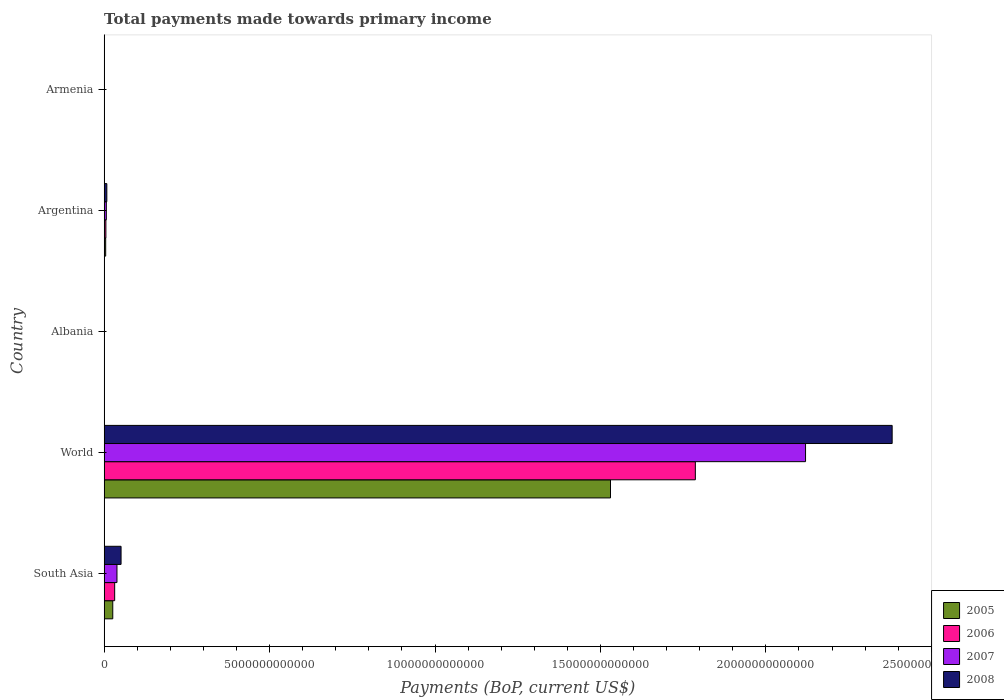How many different coloured bars are there?
Make the answer very short. 4. Are the number of bars per tick equal to the number of legend labels?
Your answer should be very brief. Yes. Are the number of bars on each tick of the Y-axis equal?
Make the answer very short. Yes. How many bars are there on the 2nd tick from the top?
Offer a terse response. 4. How many bars are there on the 3rd tick from the bottom?
Your response must be concise. 4. What is the label of the 5th group of bars from the top?
Give a very brief answer. South Asia. What is the total payments made towards primary income in 2006 in World?
Give a very brief answer. 1.79e+13. Across all countries, what is the maximum total payments made towards primary income in 2007?
Offer a terse response. 2.12e+13. Across all countries, what is the minimum total payments made towards primary income in 2008?
Give a very brief answer. 5.51e+09. In which country was the total payments made towards primary income in 2005 minimum?
Your answer should be compact. Armenia. What is the total total payments made towards primary income in 2006 in the graph?
Make the answer very short. 1.82e+13. What is the difference between the total payments made towards primary income in 2006 in Armenia and that in World?
Provide a succinct answer. -1.79e+13. What is the difference between the total payments made towards primary income in 2008 in Albania and the total payments made towards primary income in 2007 in Argentina?
Offer a very short reply. -5.86e+1. What is the average total payments made towards primary income in 2007 per country?
Your answer should be very brief. 4.33e+12. What is the difference between the total payments made towards primary income in 2006 and total payments made towards primary income in 2007 in South Asia?
Give a very brief answer. -6.95e+1. In how many countries, is the total payments made towards primary income in 2005 greater than 6000000000000 US$?
Provide a short and direct response. 1. What is the ratio of the total payments made towards primary income in 2005 in Argentina to that in World?
Make the answer very short. 0. What is the difference between the highest and the second highest total payments made towards primary income in 2008?
Offer a terse response. 2.33e+13. What is the difference between the highest and the lowest total payments made towards primary income in 2008?
Provide a short and direct response. 2.38e+13. In how many countries, is the total payments made towards primary income in 2007 greater than the average total payments made towards primary income in 2007 taken over all countries?
Your response must be concise. 1. Is the sum of the total payments made towards primary income in 2008 in Armenia and South Asia greater than the maximum total payments made towards primary income in 2005 across all countries?
Make the answer very short. No. What does the 4th bar from the top in South Asia represents?
Provide a short and direct response. 2005. What does the 2nd bar from the bottom in South Asia represents?
Offer a very short reply. 2006. How many countries are there in the graph?
Make the answer very short. 5. What is the difference between two consecutive major ticks on the X-axis?
Provide a short and direct response. 5.00e+12. Are the values on the major ticks of X-axis written in scientific E-notation?
Provide a succinct answer. No. Does the graph contain any zero values?
Give a very brief answer. No. Where does the legend appear in the graph?
Offer a very short reply. Bottom right. How are the legend labels stacked?
Your response must be concise. Vertical. What is the title of the graph?
Your answer should be compact. Total payments made towards primary income. What is the label or title of the X-axis?
Ensure brevity in your answer.  Payments (BoP, current US$). What is the label or title of the Y-axis?
Provide a succinct answer. Country. What is the Payments (BoP, current US$) in 2005 in South Asia?
Give a very brief answer. 2.61e+11. What is the Payments (BoP, current US$) in 2006 in South Asia?
Your response must be concise. 3.18e+11. What is the Payments (BoP, current US$) in 2007 in South Asia?
Your answer should be very brief. 3.88e+11. What is the Payments (BoP, current US$) in 2008 in South Asia?
Your answer should be very brief. 5.11e+11. What is the Payments (BoP, current US$) in 2005 in World?
Your answer should be very brief. 1.53e+13. What is the Payments (BoP, current US$) in 2006 in World?
Give a very brief answer. 1.79e+13. What is the Payments (BoP, current US$) of 2007 in World?
Make the answer very short. 2.12e+13. What is the Payments (BoP, current US$) in 2008 in World?
Your response must be concise. 2.38e+13. What is the Payments (BoP, current US$) of 2005 in Albania?
Offer a very short reply. 3.55e+09. What is the Payments (BoP, current US$) in 2006 in Albania?
Your answer should be very brief. 4.14e+09. What is the Payments (BoP, current US$) in 2007 in Albania?
Offer a terse response. 5.43e+09. What is the Payments (BoP, current US$) in 2008 in Albania?
Give a very brief answer. 7.15e+09. What is the Payments (BoP, current US$) in 2005 in Argentina?
Ensure brevity in your answer.  4.64e+1. What is the Payments (BoP, current US$) in 2006 in Argentina?
Offer a terse response. 5.28e+1. What is the Payments (BoP, current US$) in 2007 in Argentina?
Offer a very short reply. 6.58e+1. What is the Payments (BoP, current US$) of 2008 in Argentina?
Make the answer very short. 8.10e+1. What is the Payments (BoP, current US$) of 2005 in Armenia?
Make the answer very short. 2.52e+09. What is the Payments (BoP, current US$) in 2006 in Armenia?
Offer a terse response. 3.04e+09. What is the Payments (BoP, current US$) of 2007 in Armenia?
Provide a succinct answer. 4.33e+09. What is the Payments (BoP, current US$) in 2008 in Armenia?
Ensure brevity in your answer.  5.51e+09. Across all countries, what is the maximum Payments (BoP, current US$) in 2005?
Ensure brevity in your answer.  1.53e+13. Across all countries, what is the maximum Payments (BoP, current US$) of 2006?
Your answer should be very brief. 1.79e+13. Across all countries, what is the maximum Payments (BoP, current US$) in 2007?
Keep it short and to the point. 2.12e+13. Across all countries, what is the maximum Payments (BoP, current US$) of 2008?
Offer a very short reply. 2.38e+13. Across all countries, what is the minimum Payments (BoP, current US$) of 2005?
Make the answer very short. 2.52e+09. Across all countries, what is the minimum Payments (BoP, current US$) of 2006?
Keep it short and to the point. 3.04e+09. Across all countries, what is the minimum Payments (BoP, current US$) of 2007?
Your answer should be very brief. 4.33e+09. Across all countries, what is the minimum Payments (BoP, current US$) in 2008?
Offer a very short reply. 5.51e+09. What is the total Payments (BoP, current US$) of 2005 in the graph?
Offer a very short reply. 1.56e+13. What is the total Payments (BoP, current US$) in 2006 in the graph?
Your response must be concise. 1.82e+13. What is the total Payments (BoP, current US$) of 2007 in the graph?
Provide a succinct answer. 2.17e+13. What is the total Payments (BoP, current US$) in 2008 in the graph?
Ensure brevity in your answer.  2.44e+13. What is the difference between the Payments (BoP, current US$) in 2005 in South Asia and that in World?
Provide a succinct answer. -1.50e+13. What is the difference between the Payments (BoP, current US$) of 2006 in South Asia and that in World?
Give a very brief answer. -1.75e+13. What is the difference between the Payments (BoP, current US$) in 2007 in South Asia and that in World?
Provide a succinct answer. -2.08e+13. What is the difference between the Payments (BoP, current US$) in 2008 in South Asia and that in World?
Keep it short and to the point. -2.33e+13. What is the difference between the Payments (BoP, current US$) in 2005 in South Asia and that in Albania?
Keep it short and to the point. 2.57e+11. What is the difference between the Payments (BoP, current US$) in 2006 in South Asia and that in Albania?
Ensure brevity in your answer.  3.14e+11. What is the difference between the Payments (BoP, current US$) in 2007 in South Asia and that in Albania?
Offer a very short reply. 3.82e+11. What is the difference between the Payments (BoP, current US$) in 2008 in South Asia and that in Albania?
Provide a succinct answer. 5.04e+11. What is the difference between the Payments (BoP, current US$) in 2005 in South Asia and that in Argentina?
Ensure brevity in your answer.  2.14e+11. What is the difference between the Payments (BoP, current US$) of 2006 in South Asia and that in Argentina?
Your answer should be very brief. 2.65e+11. What is the difference between the Payments (BoP, current US$) of 2007 in South Asia and that in Argentina?
Your answer should be very brief. 3.22e+11. What is the difference between the Payments (BoP, current US$) in 2008 in South Asia and that in Argentina?
Provide a short and direct response. 4.30e+11. What is the difference between the Payments (BoP, current US$) in 2005 in South Asia and that in Armenia?
Give a very brief answer. 2.58e+11. What is the difference between the Payments (BoP, current US$) of 2006 in South Asia and that in Armenia?
Make the answer very short. 3.15e+11. What is the difference between the Payments (BoP, current US$) in 2007 in South Asia and that in Armenia?
Your answer should be compact. 3.83e+11. What is the difference between the Payments (BoP, current US$) in 2008 in South Asia and that in Armenia?
Offer a terse response. 5.06e+11. What is the difference between the Payments (BoP, current US$) of 2005 in World and that in Albania?
Offer a terse response. 1.53e+13. What is the difference between the Payments (BoP, current US$) of 2006 in World and that in Albania?
Your answer should be very brief. 1.79e+13. What is the difference between the Payments (BoP, current US$) in 2007 in World and that in Albania?
Ensure brevity in your answer.  2.12e+13. What is the difference between the Payments (BoP, current US$) of 2008 in World and that in Albania?
Make the answer very short. 2.38e+13. What is the difference between the Payments (BoP, current US$) of 2005 in World and that in Argentina?
Your answer should be very brief. 1.53e+13. What is the difference between the Payments (BoP, current US$) of 2006 in World and that in Argentina?
Offer a terse response. 1.78e+13. What is the difference between the Payments (BoP, current US$) of 2007 in World and that in Argentina?
Your response must be concise. 2.11e+13. What is the difference between the Payments (BoP, current US$) of 2008 in World and that in Argentina?
Provide a succinct answer. 2.37e+13. What is the difference between the Payments (BoP, current US$) in 2005 in World and that in Armenia?
Your response must be concise. 1.53e+13. What is the difference between the Payments (BoP, current US$) of 2006 in World and that in Armenia?
Provide a succinct answer. 1.79e+13. What is the difference between the Payments (BoP, current US$) of 2007 in World and that in Armenia?
Keep it short and to the point. 2.12e+13. What is the difference between the Payments (BoP, current US$) in 2008 in World and that in Armenia?
Ensure brevity in your answer.  2.38e+13. What is the difference between the Payments (BoP, current US$) of 2005 in Albania and that in Argentina?
Offer a terse response. -4.29e+1. What is the difference between the Payments (BoP, current US$) in 2006 in Albania and that in Argentina?
Your answer should be very brief. -4.87e+1. What is the difference between the Payments (BoP, current US$) of 2007 in Albania and that in Argentina?
Ensure brevity in your answer.  -6.04e+1. What is the difference between the Payments (BoP, current US$) in 2008 in Albania and that in Argentina?
Give a very brief answer. -7.39e+1. What is the difference between the Payments (BoP, current US$) of 2005 in Albania and that in Armenia?
Keep it short and to the point. 1.03e+09. What is the difference between the Payments (BoP, current US$) of 2006 in Albania and that in Armenia?
Your answer should be compact. 1.11e+09. What is the difference between the Payments (BoP, current US$) in 2007 in Albania and that in Armenia?
Offer a very short reply. 1.09e+09. What is the difference between the Payments (BoP, current US$) of 2008 in Albania and that in Armenia?
Provide a succinct answer. 1.64e+09. What is the difference between the Payments (BoP, current US$) in 2005 in Argentina and that in Armenia?
Your answer should be compact. 4.39e+1. What is the difference between the Payments (BoP, current US$) in 2006 in Argentina and that in Armenia?
Offer a very short reply. 4.98e+1. What is the difference between the Payments (BoP, current US$) in 2007 in Argentina and that in Armenia?
Your answer should be very brief. 6.15e+1. What is the difference between the Payments (BoP, current US$) of 2008 in Argentina and that in Armenia?
Provide a succinct answer. 7.55e+1. What is the difference between the Payments (BoP, current US$) in 2005 in South Asia and the Payments (BoP, current US$) in 2006 in World?
Keep it short and to the point. -1.76e+13. What is the difference between the Payments (BoP, current US$) of 2005 in South Asia and the Payments (BoP, current US$) of 2007 in World?
Keep it short and to the point. -2.09e+13. What is the difference between the Payments (BoP, current US$) in 2005 in South Asia and the Payments (BoP, current US$) in 2008 in World?
Keep it short and to the point. -2.36e+13. What is the difference between the Payments (BoP, current US$) in 2006 in South Asia and the Payments (BoP, current US$) in 2007 in World?
Provide a short and direct response. -2.09e+13. What is the difference between the Payments (BoP, current US$) of 2006 in South Asia and the Payments (BoP, current US$) of 2008 in World?
Ensure brevity in your answer.  -2.35e+13. What is the difference between the Payments (BoP, current US$) in 2007 in South Asia and the Payments (BoP, current US$) in 2008 in World?
Keep it short and to the point. -2.34e+13. What is the difference between the Payments (BoP, current US$) of 2005 in South Asia and the Payments (BoP, current US$) of 2006 in Albania?
Your response must be concise. 2.56e+11. What is the difference between the Payments (BoP, current US$) in 2005 in South Asia and the Payments (BoP, current US$) in 2007 in Albania?
Your answer should be very brief. 2.55e+11. What is the difference between the Payments (BoP, current US$) of 2005 in South Asia and the Payments (BoP, current US$) of 2008 in Albania?
Give a very brief answer. 2.53e+11. What is the difference between the Payments (BoP, current US$) in 2006 in South Asia and the Payments (BoP, current US$) in 2007 in Albania?
Make the answer very short. 3.13e+11. What is the difference between the Payments (BoP, current US$) in 2006 in South Asia and the Payments (BoP, current US$) in 2008 in Albania?
Make the answer very short. 3.11e+11. What is the difference between the Payments (BoP, current US$) of 2007 in South Asia and the Payments (BoP, current US$) of 2008 in Albania?
Your answer should be compact. 3.80e+11. What is the difference between the Payments (BoP, current US$) in 2005 in South Asia and the Payments (BoP, current US$) in 2006 in Argentina?
Offer a terse response. 2.08e+11. What is the difference between the Payments (BoP, current US$) in 2005 in South Asia and the Payments (BoP, current US$) in 2007 in Argentina?
Offer a very short reply. 1.95e+11. What is the difference between the Payments (BoP, current US$) of 2005 in South Asia and the Payments (BoP, current US$) of 2008 in Argentina?
Your answer should be compact. 1.79e+11. What is the difference between the Payments (BoP, current US$) in 2006 in South Asia and the Payments (BoP, current US$) in 2007 in Argentina?
Make the answer very short. 2.52e+11. What is the difference between the Payments (BoP, current US$) of 2006 in South Asia and the Payments (BoP, current US$) of 2008 in Argentina?
Your answer should be compact. 2.37e+11. What is the difference between the Payments (BoP, current US$) in 2007 in South Asia and the Payments (BoP, current US$) in 2008 in Argentina?
Provide a succinct answer. 3.07e+11. What is the difference between the Payments (BoP, current US$) of 2005 in South Asia and the Payments (BoP, current US$) of 2006 in Armenia?
Keep it short and to the point. 2.57e+11. What is the difference between the Payments (BoP, current US$) in 2005 in South Asia and the Payments (BoP, current US$) in 2007 in Armenia?
Your response must be concise. 2.56e+11. What is the difference between the Payments (BoP, current US$) in 2005 in South Asia and the Payments (BoP, current US$) in 2008 in Armenia?
Provide a succinct answer. 2.55e+11. What is the difference between the Payments (BoP, current US$) of 2006 in South Asia and the Payments (BoP, current US$) of 2007 in Armenia?
Your response must be concise. 3.14e+11. What is the difference between the Payments (BoP, current US$) in 2006 in South Asia and the Payments (BoP, current US$) in 2008 in Armenia?
Your answer should be very brief. 3.12e+11. What is the difference between the Payments (BoP, current US$) in 2007 in South Asia and the Payments (BoP, current US$) in 2008 in Armenia?
Make the answer very short. 3.82e+11. What is the difference between the Payments (BoP, current US$) in 2005 in World and the Payments (BoP, current US$) in 2006 in Albania?
Your response must be concise. 1.53e+13. What is the difference between the Payments (BoP, current US$) of 2005 in World and the Payments (BoP, current US$) of 2007 in Albania?
Offer a very short reply. 1.53e+13. What is the difference between the Payments (BoP, current US$) in 2005 in World and the Payments (BoP, current US$) in 2008 in Albania?
Ensure brevity in your answer.  1.53e+13. What is the difference between the Payments (BoP, current US$) in 2006 in World and the Payments (BoP, current US$) in 2007 in Albania?
Ensure brevity in your answer.  1.79e+13. What is the difference between the Payments (BoP, current US$) of 2006 in World and the Payments (BoP, current US$) of 2008 in Albania?
Keep it short and to the point. 1.79e+13. What is the difference between the Payments (BoP, current US$) of 2007 in World and the Payments (BoP, current US$) of 2008 in Albania?
Provide a short and direct response. 2.12e+13. What is the difference between the Payments (BoP, current US$) in 2005 in World and the Payments (BoP, current US$) in 2006 in Argentina?
Give a very brief answer. 1.53e+13. What is the difference between the Payments (BoP, current US$) in 2005 in World and the Payments (BoP, current US$) in 2007 in Argentina?
Provide a short and direct response. 1.52e+13. What is the difference between the Payments (BoP, current US$) in 2005 in World and the Payments (BoP, current US$) in 2008 in Argentina?
Your response must be concise. 1.52e+13. What is the difference between the Payments (BoP, current US$) of 2006 in World and the Payments (BoP, current US$) of 2007 in Argentina?
Offer a terse response. 1.78e+13. What is the difference between the Payments (BoP, current US$) of 2006 in World and the Payments (BoP, current US$) of 2008 in Argentina?
Keep it short and to the point. 1.78e+13. What is the difference between the Payments (BoP, current US$) of 2007 in World and the Payments (BoP, current US$) of 2008 in Argentina?
Provide a succinct answer. 2.11e+13. What is the difference between the Payments (BoP, current US$) in 2005 in World and the Payments (BoP, current US$) in 2006 in Armenia?
Provide a succinct answer. 1.53e+13. What is the difference between the Payments (BoP, current US$) in 2005 in World and the Payments (BoP, current US$) in 2007 in Armenia?
Provide a short and direct response. 1.53e+13. What is the difference between the Payments (BoP, current US$) in 2005 in World and the Payments (BoP, current US$) in 2008 in Armenia?
Your response must be concise. 1.53e+13. What is the difference between the Payments (BoP, current US$) of 2006 in World and the Payments (BoP, current US$) of 2007 in Armenia?
Your answer should be compact. 1.79e+13. What is the difference between the Payments (BoP, current US$) in 2006 in World and the Payments (BoP, current US$) in 2008 in Armenia?
Ensure brevity in your answer.  1.79e+13. What is the difference between the Payments (BoP, current US$) of 2007 in World and the Payments (BoP, current US$) of 2008 in Armenia?
Give a very brief answer. 2.12e+13. What is the difference between the Payments (BoP, current US$) in 2005 in Albania and the Payments (BoP, current US$) in 2006 in Argentina?
Provide a short and direct response. -4.93e+1. What is the difference between the Payments (BoP, current US$) of 2005 in Albania and the Payments (BoP, current US$) of 2007 in Argentina?
Provide a short and direct response. -6.22e+1. What is the difference between the Payments (BoP, current US$) in 2005 in Albania and the Payments (BoP, current US$) in 2008 in Argentina?
Ensure brevity in your answer.  -7.75e+1. What is the difference between the Payments (BoP, current US$) of 2006 in Albania and the Payments (BoP, current US$) of 2007 in Argentina?
Make the answer very short. -6.17e+1. What is the difference between the Payments (BoP, current US$) of 2006 in Albania and the Payments (BoP, current US$) of 2008 in Argentina?
Your answer should be compact. -7.69e+1. What is the difference between the Payments (BoP, current US$) of 2007 in Albania and the Payments (BoP, current US$) of 2008 in Argentina?
Provide a short and direct response. -7.56e+1. What is the difference between the Payments (BoP, current US$) of 2005 in Albania and the Payments (BoP, current US$) of 2006 in Armenia?
Provide a short and direct response. 5.17e+08. What is the difference between the Payments (BoP, current US$) of 2005 in Albania and the Payments (BoP, current US$) of 2007 in Armenia?
Make the answer very short. -7.81e+08. What is the difference between the Payments (BoP, current US$) in 2005 in Albania and the Payments (BoP, current US$) in 2008 in Armenia?
Offer a terse response. -1.96e+09. What is the difference between the Payments (BoP, current US$) of 2006 in Albania and the Payments (BoP, current US$) of 2007 in Armenia?
Ensure brevity in your answer.  -1.92e+08. What is the difference between the Payments (BoP, current US$) in 2006 in Albania and the Payments (BoP, current US$) in 2008 in Armenia?
Provide a succinct answer. -1.37e+09. What is the difference between the Payments (BoP, current US$) of 2007 in Albania and the Payments (BoP, current US$) of 2008 in Armenia?
Offer a very short reply. -8.38e+07. What is the difference between the Payments (BoP, current US$) in 2005 in Argentina and the Payments (BoP, current US$) in 2006 in Armenia?
Provide a short and direct response. 4.34e+1. What is the difference between the Payments (BoP, current US$) of 2005 in Argentina and the Payments (BoP, current US$) of 2007 in Armenia?
Offer a terse response. 4.21e+1. What is the difference between the Payments (BoP, current US$) in 2005 in Argentina and the Payments (BoP, current US$) in 2008 in Armenia?
Ensure brevity in your answer.  4.09e+1. What is the difference between the Payments (BoP, current US$) in 2006 in Argentina and the Payments (BoP, current US$) in 2007 in Armenia?
Your answer should be compact. 4.85e+1. What is the difference between the Payments (BoP, current US$) of 2006 in Argentina and the Payments (BoP, current US$) of 2008 in Armenia?
Offer a terse response. 4.73e+1. What is the difference between the Payments (BoP, current US$) of 2007 in Argentina and the Payments (BoP, current US$) of 2008 in Armenia?
Give a very brief answer. 6.03e+1. What is the average Payments (BoP, current US$) in 2005 per country?
Offer a terse response. 3.12e+12. What is the average Payments (BoP, current US$) of 2006 per country?
Your answer should be very brief. 3.65e+12. What is the average Payments (BoP, current US$) in 2007 per country?
Ensure brevity in your answer.  4.33e+12. What is the average Payments (BoP, current US$) of 2008 per country?
Keep it short and to the point. 4.88e+12. What is the difference between the Payments (BoP, current US$) of 2005 and Payments (BoP, current US$) of 2006 in South Asia?
Offer a very short reply. -5.75e+1. What is the difference between the Payments (BoP, current US$) in 2005 and Payments (BoP, current US$) in 2007 in South Asia?
Your answer should be compact. -1.27e+11. What is the difference between the Payments (BoP, current US$) in 2005 and Payments (BoP, current US$) in 2008 in South Asia?
Provide a succinct answer. -2.51e+11. What is the difference between the Payments (BoP, current US$) in 2006 and Payments (BoP, current US$) in 2007 in South Asia?
Provide a short and direct response. -6.95e+1. What is the difference between the Payments (BoP, current US$) of 2006 and Payments (BoP, current US$) of 2008 in South Asia?
Your answer should be compact. -1.93e+11. What is the difference between the Payments (BoP, current US$) in 2007 and Payments (BoP, current US$) in 2008 in South Asia?
Offer a terse response. -1.24e+11. What is the difference between the Payments (BoP, current US$) of 2005 and Payments (BoP, current US$) of 2006 in World?
Provide a short and direct response. -2.56e+12. What is the difference between the Payments (BoP, current US$) of 2005 and Payments (BoP, current US$) of 2007 in World?
Provide a short and direct response. -5.89e+12. What is the difference between the Payments (BoP, current US$) in 2005 and Payments (BoP, current US$) in 2008 in World?
Offer a very short reply. -8.51e+12. What is the difference between the Payments (BoP, current US$) of 2006 and Payments (BoP, current US$) of 2007 in World?
Make the answer very short. -3.33e+12. What is the difference between the Payments (BoP, current US$) in 2006 and Payments (BoP, current US$) in 2008 in World?
Make the answer very short. -5.95e+12. What is the difference between the Payments (BoP, current US$) of 2007 and Payments (BoP, current US$) of 2008 in World?
Offer a terse response. -2.62e+12. What is the difference between the Payments (BoP, current US$) in 2005 and Payments (BoP, current US$) in 2006 in Albania?
Keep it short and to the point. -5.89e+08. What is the difference between the Payments (BoP, current US$) in 2005 and Payments (BoP, current US$) in 2007 in Albania?
Offer a very short reply. -1.88e+09. What is the difference between the Payments (BoP, current US$) of 2005 and Payments (BoP, current US$) of 2008 in Albania?
Provide a short and direct response. -3.60e+09. What is the difference between the Payments (BoP, current US$) of 2006 and Payments (BoP, current US$) of 2007 in Albania?
Your response must be concise. -1.29e+09. What is the difference between the Payments (BoP, current US$) in 2006 and Payments (BoP, current US$) in 2008 in Albania?
Keep it short and to the point. -3.01e+09. What is the difference between the Payments (BoP, current US$) of 2007 and Payments (BoP, current US$) of 2008 in Albania?
Keep it short and to the point. -1.72e+09. What is the difference between the Payments (BoP, current US$) of 2005 and Payments (BoP, current US$) of 2006 in Argentina?
Keep it short and to the point. -6.39e+09. What is the difference between the Payments (BoP, current US$) of 2005 and Payments (BoP, current US$) of 2007 in Argentina?
Your answer should be very brief. -1.94e+1. What is the difference between the Payments (BoP, current US$) of 2005 and Payments (BoP, current US$) of 2008 in Argentina?
Your answer should be compact. -3.46e+1. What is the difference between the Payments (BoP, current US$) of 2006 and Payments (BoP, current US$) of 2007 in Argentina?
Give a very brief answer. -1.30e+1. What is the difference between the Payments (BoP, current US$) in 2006 and Payments (BoP, current US$) in 2008 in Argentina?
Keep it short and to the point. -2.82e+1. What is the difference between the Payments (BoP, current US$) of 2007 and Payments (BoP, current US$) of 2008 in Argentina?
Ensure brevity in your answer.  -1.52e+1. What is the difference between the Payments (BoP, current US$) of 2005 and Payments (BoP, current US$) of 2006 in Armenia?
Your response must be concise. -5.16e+08. What is the difference between the Payments (BoP, current US$) of 2005 and Payments (BoP, current US$) of 2007 in Armenia?
Offer a terse response. -1.81e+09. What is the difference between the Payments (BoP, current US$) in 2005 and Payments (BoP, current US$) in 2008 in Armenia?
Keep it short and to the point. -2.99e+09. What is the difference between the Payments (BoP, current US$) in 2006 and Payments (BoP, current US$) in 2007 in Armenia?
Give a very brief answer. -1.30e+09. What is the difference between the Payments (BoP, current US$) in 2006 and Payments (BoP, current US$) in 2008 in Armenia?
Offer a very short reply. -2.48e+09. What is the difference between the Payments (BoP, current US$) in 2007 and Payments (BoP, current US$) in 2008 in Armenia?
Your response must be concise. -1.18e+09. What is the ratio of the Payments (BoP, current US$) in 2005 in South Asia to that in World?
Make the answer very short. 0.02. What is the ratio of the Payments (BoP, current US$) of 2006 in South Asia to that in World?
Your response must be concise. 0.02. What is the ratio of the Payments (BoP, current US$) of 2007 in South Asia to that in World?
Your answer should be very brief. 0.02. What is the ratio of the Payments (BoP, current US$) in 2008 in South Asia to that in World?
Your response must be concise. 0.02. What is the ratio of the Payments (BoP, current US$) in 2005 in South Asia to that in Albania?
Provide a short and direct response. 73.32. What is the ratio of the Payments (BoP, current US$) of 2006 in South Asia to that in Albania?
Offer a terse response. 76.77. What is the ratio of the Payments (BoP, current US$) in 2007 in South Asia to that in Albania?
Your answer should be very brief. 71.38. What is the ratio of the Payments (BoP, current US$) of 2008 in South Asia to that in Albania?
Offer a terse response. 71.51. What is the ratio of the Payments (BoP, current US$) of 2005 in South Asia to that in Argentina?
Keep it short and to the point. 5.61. What is the ratio of the Payments (BoP, current US$) in 2006 in South Asia to that in Argentina?
Your response must be concise. 6.02. What is the ratio of the Payments (BoP, current US$) of 2007 in South Asia to that in Argentina?
Give a very brief answer. 5.89. What is the ratio of the Payments (BoP, current US$) of 2008 in South Asia to that in Argentina?
Offer a terse response. 6.31. What is the ratio of the Payments (BoP, current US$) in 2005 in South Asia to that in Armenia?
Make the answer very short. 103.36. What is the ratio of the Payments (BoP, current US$) of 2006 in South Asia to that in Armenia?
Provide a short and direct response. 104.75. What is the ratio of the Payments (BoP, current US$) of 2007 in South Asia to that in Armenia?
Your response must be concise. 89.41. What is the ratio of the Payments (BoP, current US$) in 2008 in South Asia to that in Armenia?
Offer a terse response. 92.73. What is the ratio of the Payments (BoP, current US$) in 2005 in World to that in Albania?
Offer a terse response. 4307.27. What is the ratio of the Payments (BoP, current US$) in 2006 in World to that in Albania?
Ensure brevity in your answer.  4313.61. What is the ratio of the Payments (BoP, current US$) of 2007 in World to that in Albania?
Provide a short and direct response. 3904.49. What is the ratio of the Payments (BoP, current US$) in 2008 in World to that in Albania?
Make the answer very short. 3331.38. What is the ratio of the Payments (BoP, current US$) in 2005 in World to that in Argentina?
Keep it short and to the point. 329.72. What is the ratio of the Payments (BoP, current US$) in 2006 in World to that in Argentina?
Make the answer very short. 338.35. What is the ratio of the Payments (BoP, current US$) in 2007 in World to that in Argentina?
Provide a short and direct response. 322.2. What is the ratio of the Payments (BoP, current US$) of 2008 in World to that in Argentina?
Your answer should be compact. 293.94. What is the ratio of the Payments (BoP, current US$) of 2005 in World to that in Armenia?
Provide a short and direct response. 6072.15. What is the ratio of the Payments (BoP, current US$) in 2006 in World to that in Armenia?
Make the answer very short. 5885.54. What is the ratio of the Payments (BoP, current US$) of 2007 in World to that in Armenia?
Your answer should be very brief. 4890.82. What is the ratio of the Payments (BoP, current US$) of 2008 in World to that in Armenia?
Your answer should be very brief. 4319.9. What is the ratio of the Payments (BoP, current US$) in 2005 in Albania to that in Argentina?
Offer a terse response. 0.08. What is the ratio of the Payments (BoP, current US$) of 2006 in Albania to that in Argentina?
Your answer should be compact. 0.08. What is the ratio of the Payments (BoP, current US$) in 2007 in Albania to that in Argentina?
Give a very brief answer. 0.08. What is the ratio of the Payments (BoP, current US$) of 2008 in Albania to that in Argentina?
Make the answer very short. 0.09. What is the ratio of the Payments (BoP, current US$) of 2005 in Albania to that in Armenia?
Keep it short and to the point. 1.41. What is the ratio of the Payments (BoP, current US$) in 2006 in Albania to that in Armenia?
Ensure brevity in your answer.  1.36. What is the ratio of the Payments (BoP, current US$) of 2007 in Albania to that in Armenia?
Make the answer very short. 1.25. What is the ratio of the Payments (BoP, current US$) in 2008 in Albania to that in Armenia?
Offer a terse response. 1.3. What is the ratio of the Payments (BoP, current US$) of 2005 in Argentina to that in Armenia?
Provide a succinct answer. 18.42. What is the ratio of the Payments (BoP, current US$) in 2006 in Argentina to that in Armenia?
Offer a terse response. 17.39. What is the ratio of the Payments (BoP, current US$) in 2007 in Argentina to that in Armenia?
Your response must be concise. 15.18. What is the ratio of the Payments (BoP, current US$) of 2008 in Argentina to that in Armenia?
Your answer should be compact. 14.7. What is the difference between the highest and the second highest Payments (BoP, current US$) in 2005?
Your answer should be very brief. 1.50e+13. What is the difference between the highest and the second highest Payments (BoP, current US$) of 2006?
Ensure brevity in your answer.  1.75e+13. What is the difference between the highest and the second highest Payments (BoP, current US$) in 2007?
Your answer should be compact. 2.08e+13. What is the difference between the highest and the second highest Payments (BoP, current US$) in 2008?
Ensure brevity in your answer.  2.33e+13. What is the difference between the highest and the lowest Payments (BoP, current US$) of 2005?
Your answer should be compact. 1.53e+13. What is the difference between the highest and the lowest Payments (BoP, current US$) of 2006?
Your answer should be compact. 1.79e+13. What is the difference between the highest and the lowest Payments (BoP, current US$) in 2007?
Ensure brevity in your answer.  2.12e+13. What is the difference between the highest and the lowest Payments (BoP, current US$) of 2008?
Your answer should be very brief. 2.38e+13. 